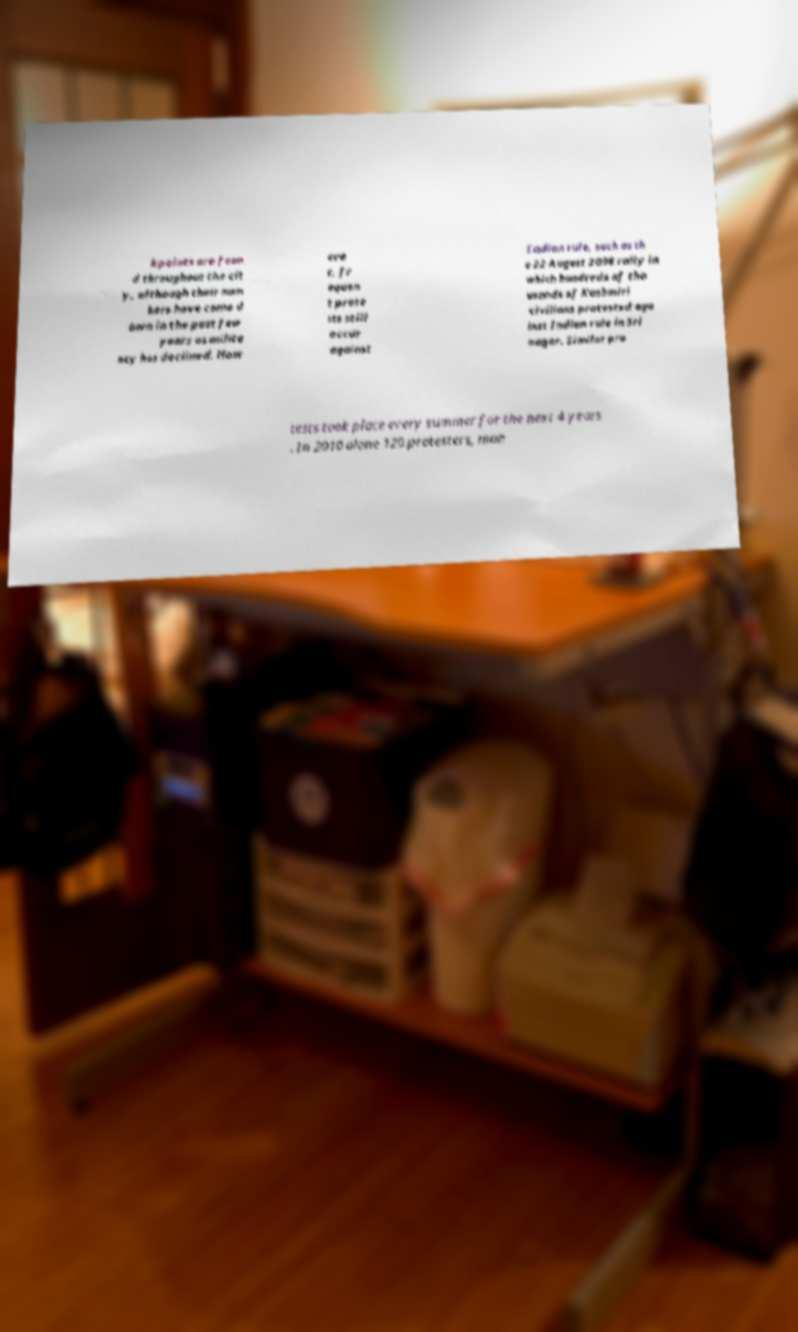Please identify and transcribe the text found in this image. kpoints are foun d throughout the cit y, although their num bers have come d own in the past few years as milita ncy has declined. How eve r, fr equen t prote sts still occur against Indian rule, such as th e 22 August 2008 rally in which hundreds of tho usands of Kashmiri civilians protested aga inst Indian rule in Sri nagar. Similar pro tests took place every summer for the next 4 years . In 2010 alone 120 protesters, man 